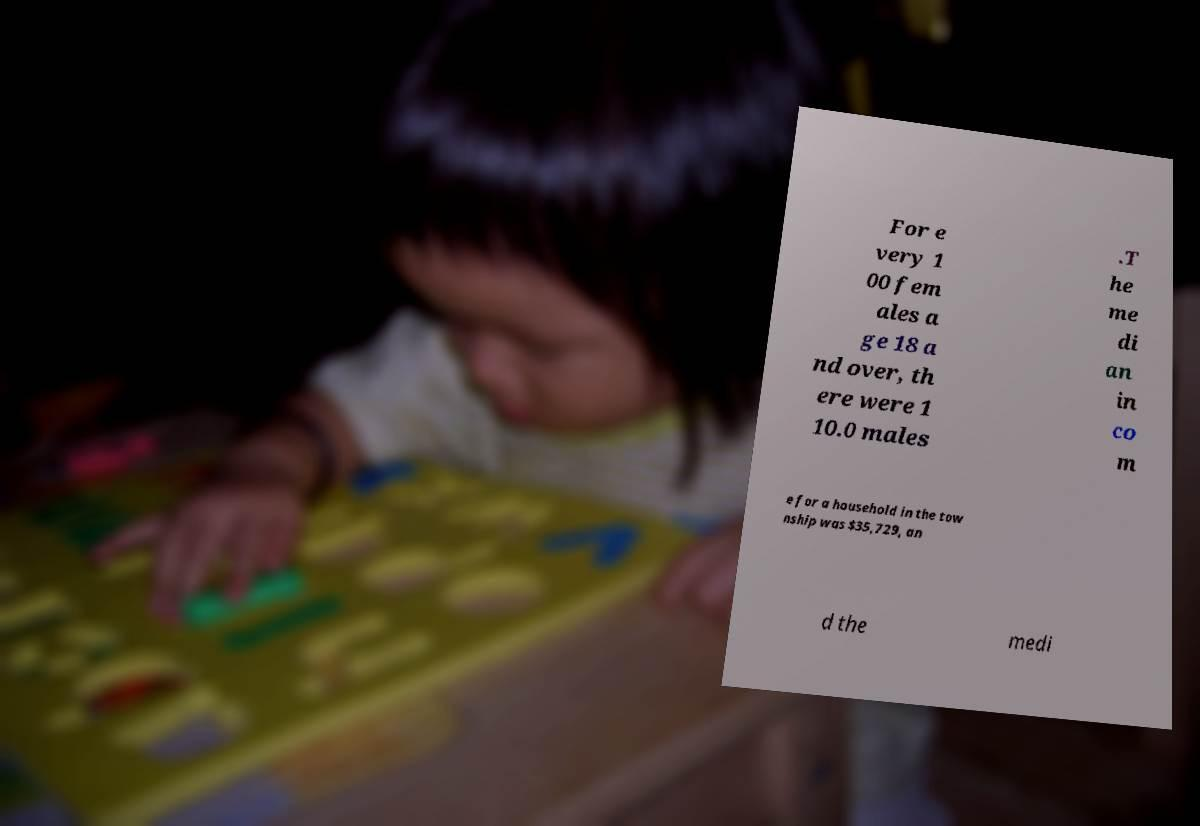Can you read and provide the text displayed in the image?This photo seems to have some interesting text. Can you extract and type it out for me? For e very 1 00 fem ales a ge 18 a nd over, th ere were 1 10.0 males .T he me di an in co m e for a household in the tow nship was $35,729, an d the medi 